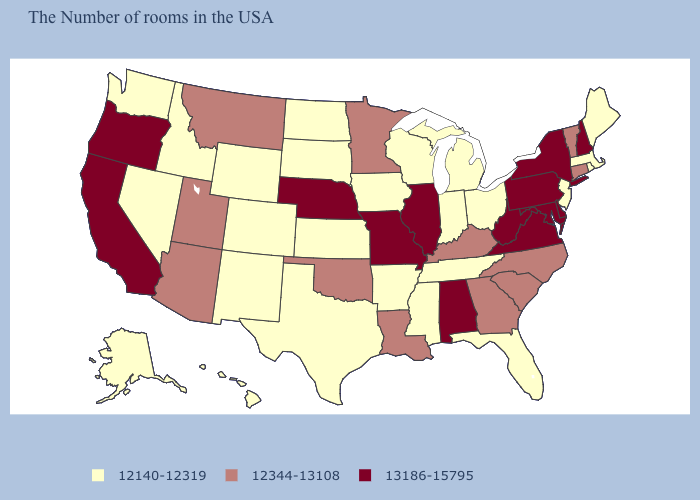Among the states that border Nebraska , does Missouri have the lowest value?
Answer briefly. No. Among the states that border Massachusetts , does Rhode Island have the lowest value?
Give a very brief answer. Yes. Name the states that have a value in the range 12140-12319?
Keep it brief. Maine, Massachusetts, Rhode Island, New Jersey, Ohio, Florida, Michigan, Indiana, Tennessee, Wisconsin, Mississippi, Arkansas, Iowa, Kansas, Texas, South Dakota, North Dakota, Wyoming, Colorado, New Mexico, Idaho, Nevada, Washington, Alaska, Hawaii. What is the value of Alaska?
Give a very brief answer. 12140-12319. Among the states that border Wisconsin , does Minnesota have the highest value?
Give a very brief answer. No. Does Alaska have the highest value in the USA?
Keep it brief. No. Does Idaho have a lower value than Texas?
Concise answer only. No. Which states have the lowest value in the South?
Keep it brief. Florida, Tennessee, Mississippi, Arkansas, Texas. What is the highest value in states that border Indiana?
Keep it brief. 13186-15795. What is the value of North Carolina?
Write a very short answer. 12344-13108. Does Virginia have the same value as Alaska?
Concise answer only. No. Name the states that have a value in the range 12140-12319?
Be succinct. Maine, Massachusetts, Rhode Island, New Jersey, Ohio, Florida, Michigan, Indiana, Tennessee, Wisconsin, Mississippi, Arkansas, Iowa, Kansas, Texas, South Dakota, North Dakota, Wyoming, Colorado, New Mexico, Idaho, Nevada, Washington, Alaska, Hawaii. Does Maryland have the same value as Alabama?
Quick response, please. Yes. What is the value of Arizona?
Short answer required. 12344-13108. Among the states that border South Carolina , which have the lowest value?
Short answer required. North Carolina, Georgia. 